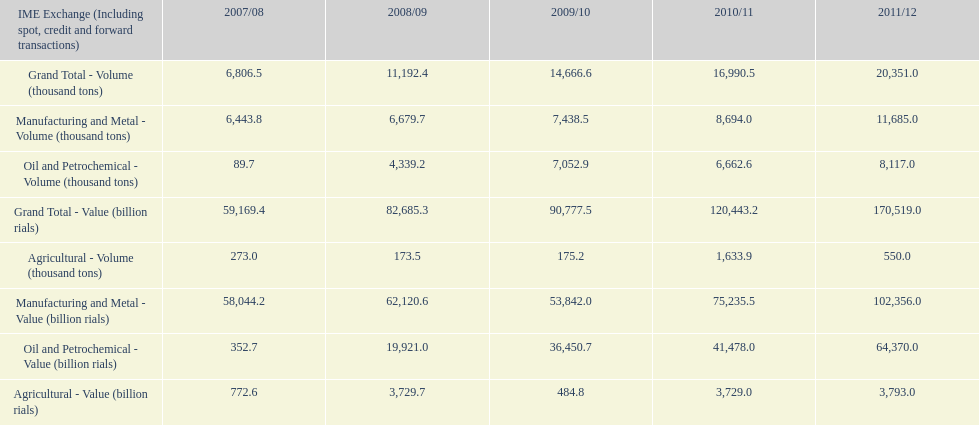How many consecutive year did the grand total value grow in iran? 4. 